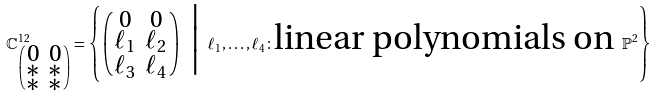<formula> <loc_0><loc_0><loc_500><loc_500>\mathbb { C } ^ { 1 2 } _ { \left ( \begin{smallmatrix} 0 & 0 \\ \ast & \ast \\ \ast & \ast \end{smallmatrix} \right ) } = \left \{ \left ( \begin{smallmatrix} 0 & 0 \\ \ell _ { 1 } & \ell _ { 2 } \\ \ell _ { 3 } & \ell _ { 4 } \end{smallmatrix} \right ) \ \Big | \ \ell _ { 1 } , \dots , \ell _ { 4 } \colon \text {linear polynomials on } \mathbb { P } ^ { 2 } \right \}</formula> 